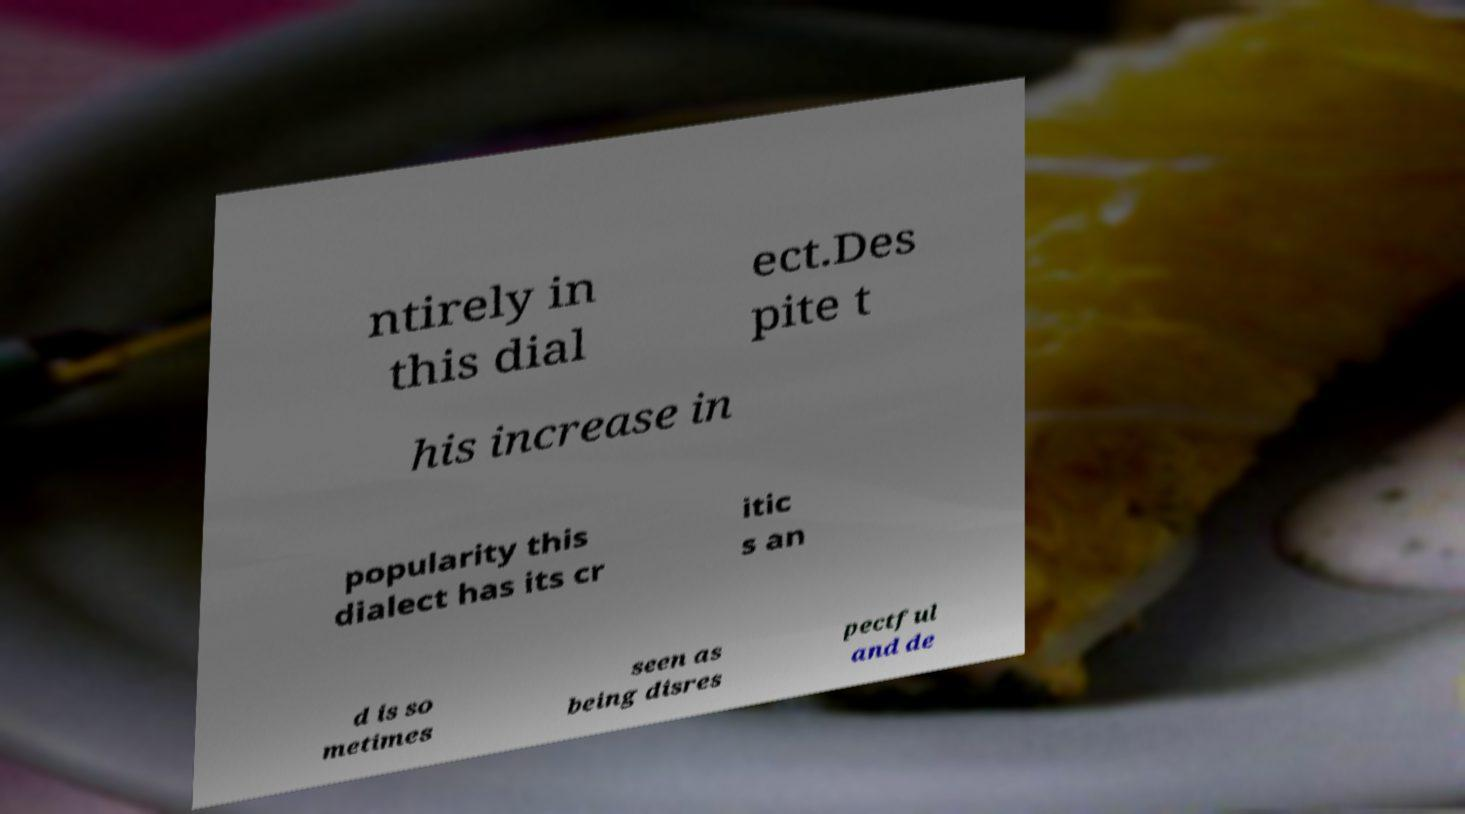Please read and relay the text visible in this image. What does it say? ntirely in this dial ect.Des pite t his increase in popularity this dialect has its cr itic s an d is so metimes seen as being disres pectful and de 